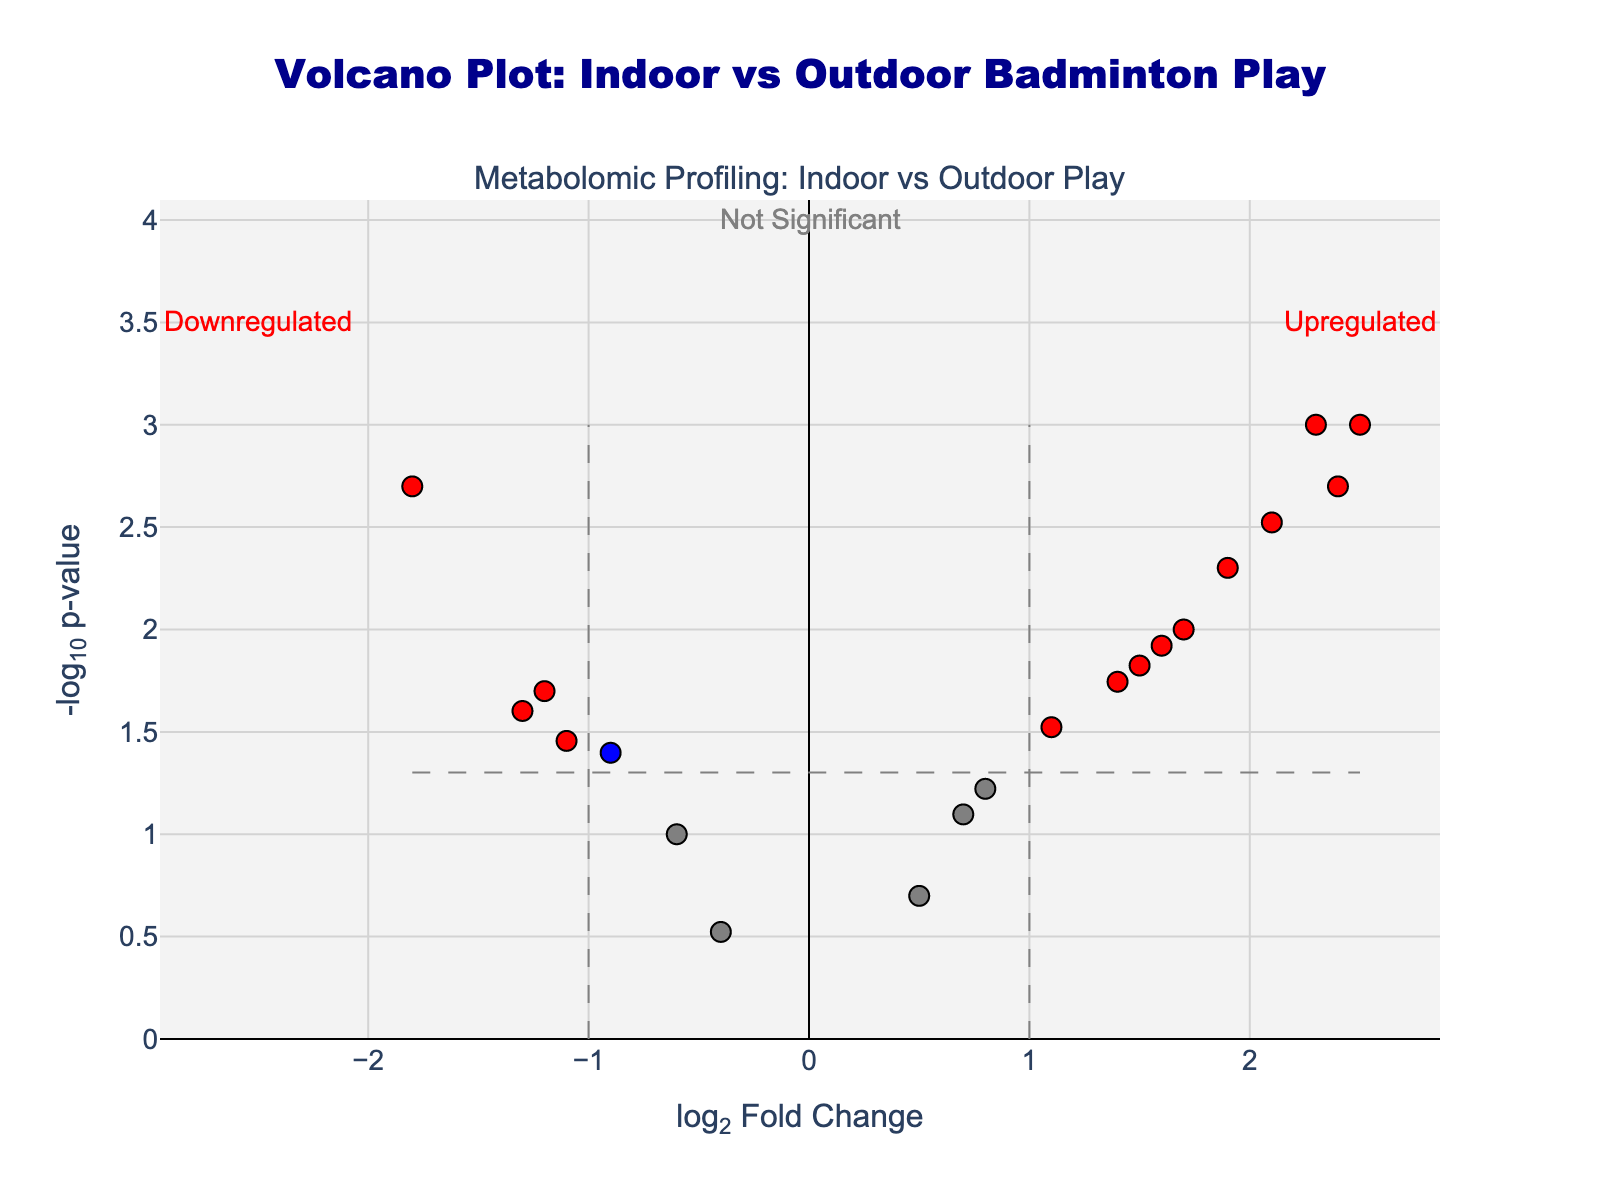What is the title of this Volcano Plot? The title of the plot is clearly displayed at the top and reads "Volcano Plot: Indoor vs Outdoor Badminton Play".
Answer: Volcano Plot: Indoor vs Outdoor Badminton Play Which metabolite has the highest log2FoldChange value? Looking at the x-axis, the metabolite with the highest log2FoldChange value, found at the farthest right point, is Pyruvate.
Answer: Pyruvate How many metabolites have negative log2FoldChange values? To answer this, count the number of data points on the left side of the y-axis (where log2FoldChange values are negative). There are six such metabolites.
Answer: Six Which metabolites show significant upregulation? Metabolites that are significantly upregulated will have a log2FoldChange > 1 and p-value < 0.05. These are colored in red and located on the right side above the threshold lines. They are Lactate, Glucose, Pyruvate, Lactic acid, Ammonia, Cortisol, Adrenaline, and Noradrenaline.
Answer: Lactate, Glucose, Pyruvate, Lactic acid, Ammonia, Cortisol, Adrenaline, Noradrenaline How many metabolites have both significant p-values and log2FoldChange values less than or equal to 1? These metabolites appear as blue points because their p-value is < 0.05 but log2FoldChange is ≤ 1. Counting these points, we identify Potassium, Glycerol, Aldosterone, Citric acid, and Bicarbonate as the five metabolites.
Answer: Five Which metabolite has the smallest p-value? The smallest p-value corresponds to the highest -log10(p-value) on the y-axis. The highest point corresponds to Lactate.
Answer: Lactate Are there any metabolites that show significant downregulation? If so, which ones? Metabolites showing significant downregulation will have a log2FoldChange < -1 and p-value < 0.05, colored in red on the left above the threshold lines. These metabolites are Creatinine, Citric acid, and Aldosterone.
Answer: Creatinine, Citric acid, Aldosterone Is there any metabolite with a log2FoldChange close to zero and a high p-value? Metabolites with log2FoldChange close to zero lie near the center of the plot. A high p-value results in a lower -log10(p-value). The metabolite close to zero and with a comparatively higher p-value is Chloride (colored in grey).
Answer: Chloride 